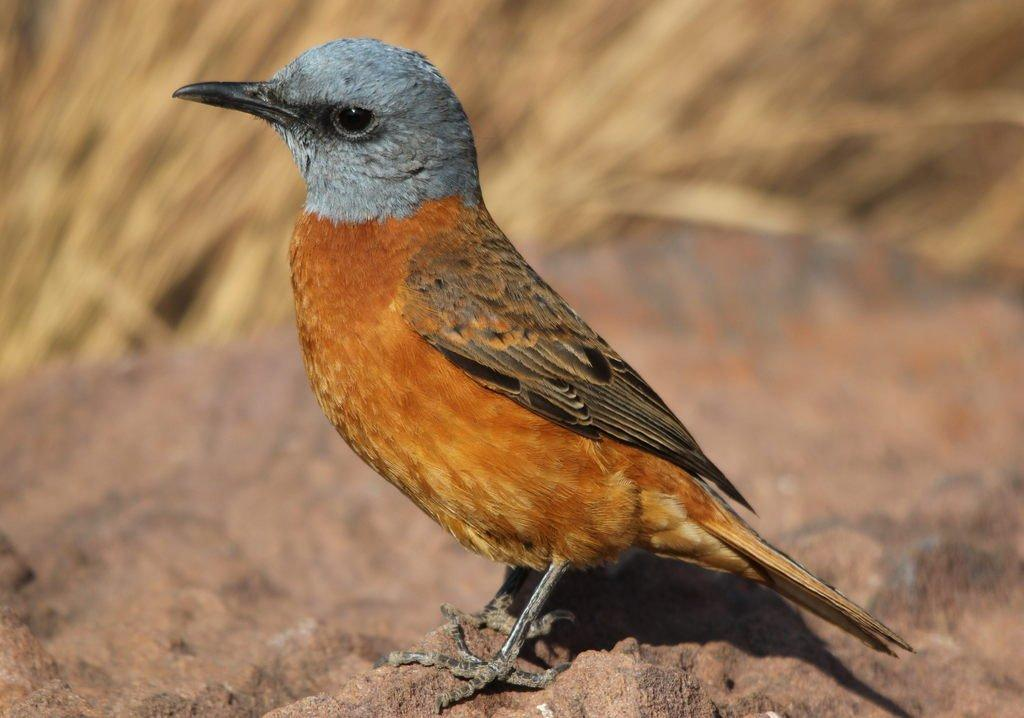Where was the image taken? The image was taken outdoors. What can be seen at the bottom of the image? There is a rock at the bottom of the image. What type of vegetation is visible in the background of the image? There is grass in the background of the image. What animal is present on the rock in the image? There is a bird on the rock in the middle of the image. What type of stick is the goat holding in the image? There is no goat or stick present in the image. What advice does the parent give to the bird in the image? There is no parent or conversation with the bird in the image. 